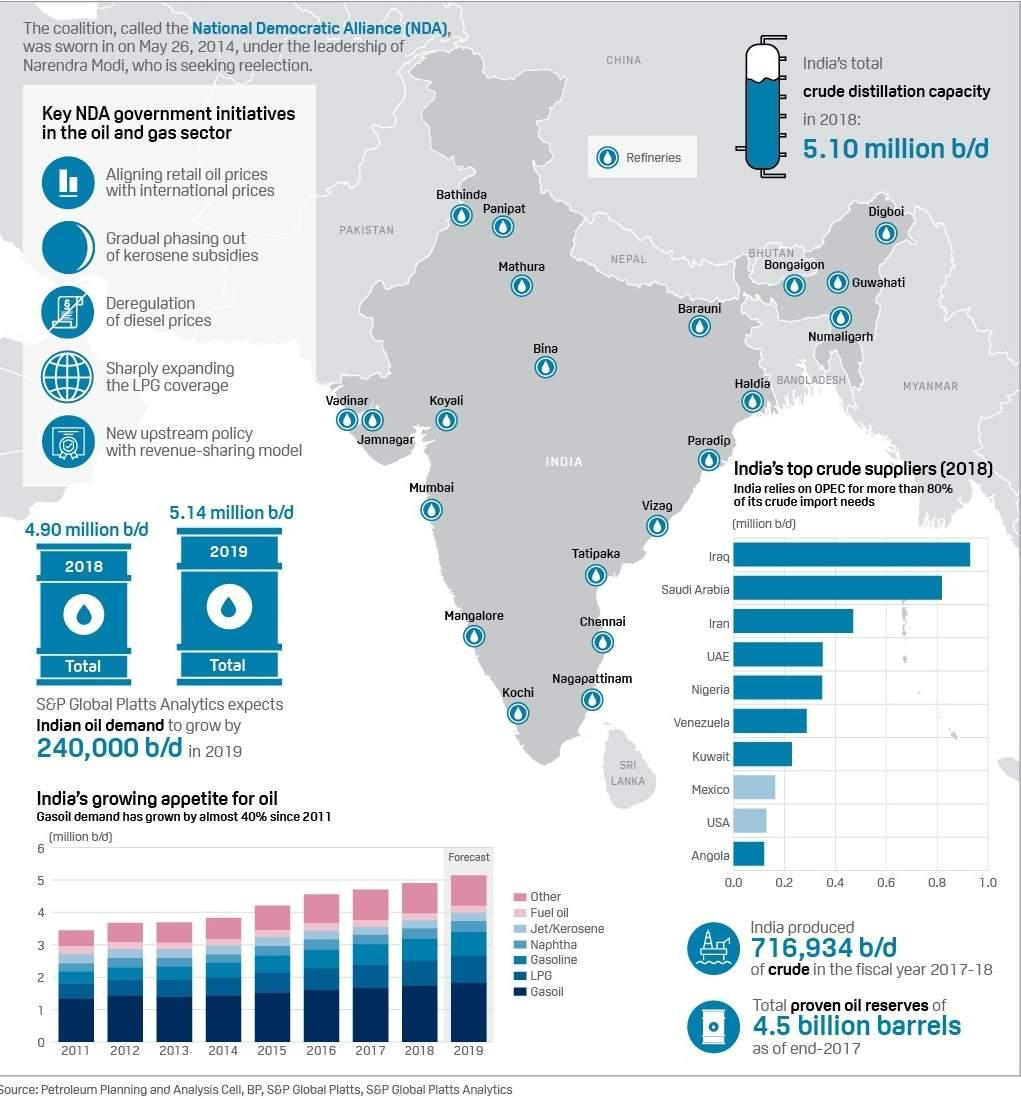Mention a couple of crucial points in this snapshot. Iraq and Saudi Arabia are countries that have crude oil suppliers above 0.8 million barrels per day. There are at least three countries that have crude oil suppliers above 0.4 million barrels per day. There are two countries that have crude oil suppliers above 0.8 million barrels per day. 